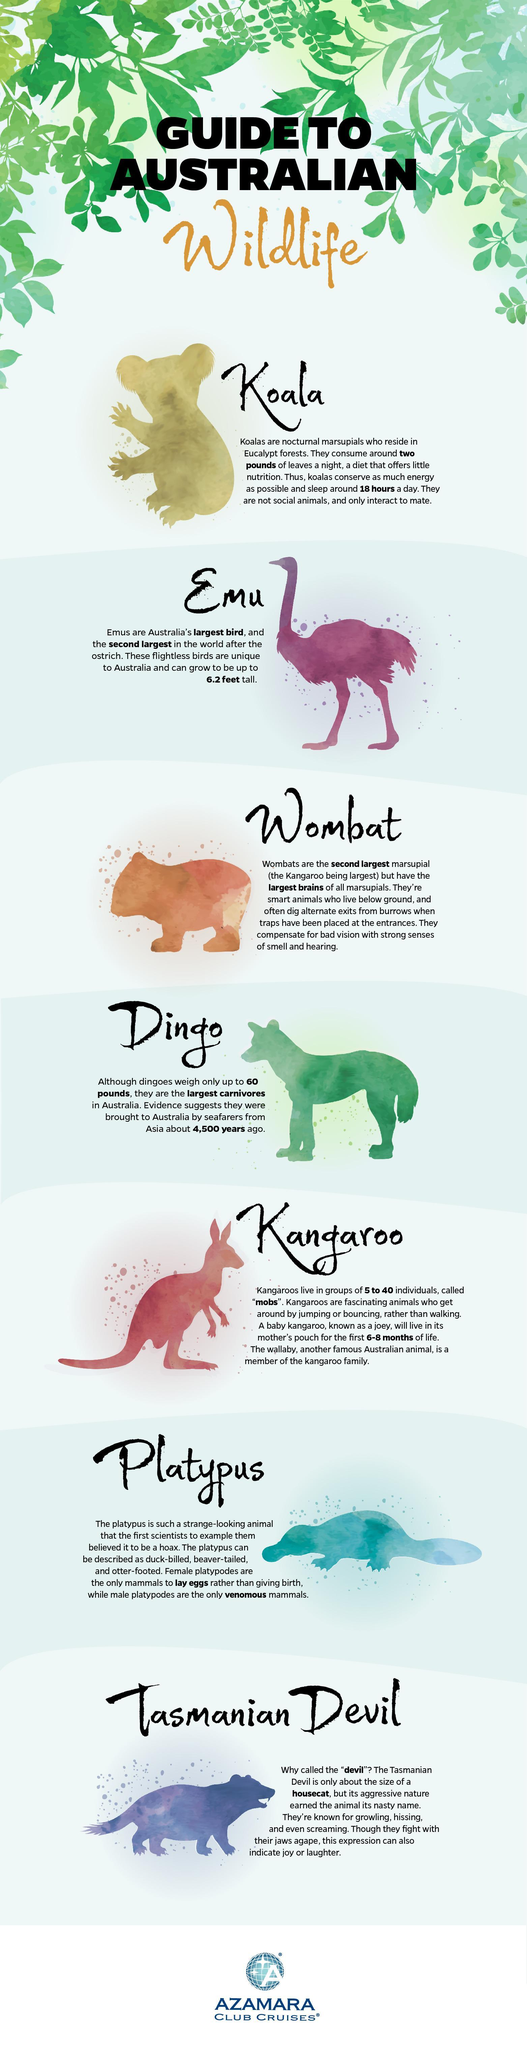How many animals are listed as Australian wildlife ?
Answer the question with a short phrase. 7 